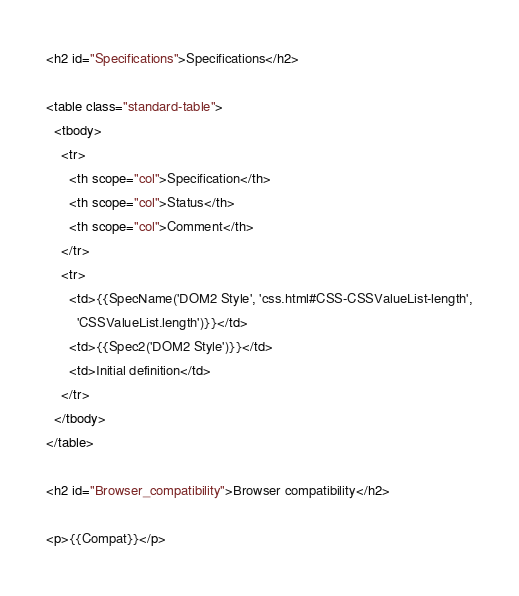Convert code to text. <code><loc_0><loc_0><loc_500><loc_500><_HTML_>
<h2 id="Specifications">Specifications</h2>

<table class="standard-table">
  <tbody>
    <tr>
      <th scope="col">Specification</th>
      <th scope="col">Status</th>
      <th scope="col">Comment</th>
    </tr>
    <tr>
      <td>{{SpecName('DOM2 Style', 'css.html#CSS-CSSValueList-length',
        'CSSValueList.length')}}</td>
      <td>{{Spec2('DOM2 Style')}}</td>
      <td>Initial definition</td>
    </tr>
  </tbody>
</table>

<h2 id="Browser_compatibility">Browser compatibility</h2>

<p>{{Compat}}</p>
</code> 